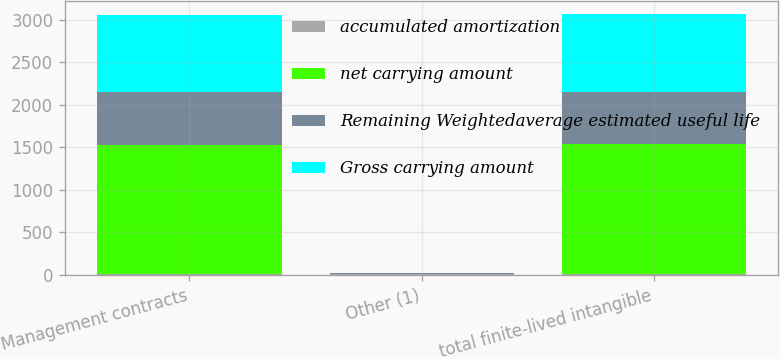Convert chart. <chart><loc_0><loc_0><loc_500><loc_500><stacked_bar_chart><ecel><fcel>Management contracts<fcel>Other (1)<fcel>total finite-lived intangible<nl><fcel>accumulated amortization<fcel>6.3<fcel>7.6<fcel>6.3<nl><fcel>net carrying amount<fcel>1524<fcel>6<fcel>1530<nl><fcel>Remaining Weightedaverage estimated useful life<fcel>613<fcel>2<fcel>615<nl><fcel>Gross carrying amount<fcel>911<fcel>4<fcel>915<nl></chart> 